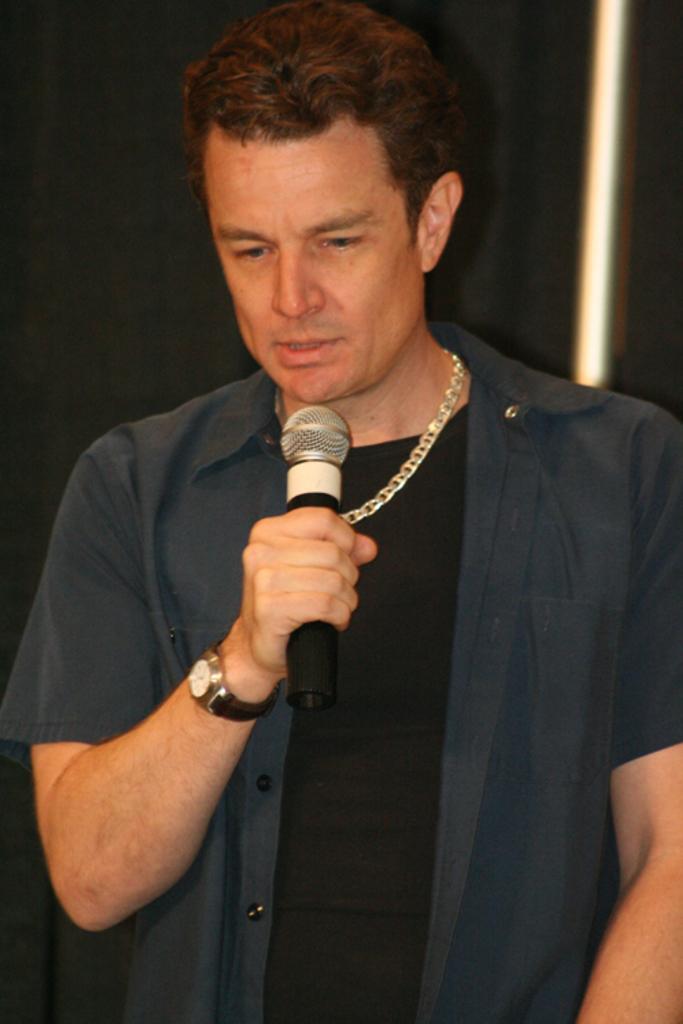Could you give a brief overview of what you see in this image? In the image there is a man who is holding a microphone and opened his mouth for talking and he is also wearing a watch which is in black color. 